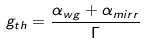<formula> <loc_0><loc_0><loc_500><loc_500>g _ { t h } = \frac { \alpha _ { w g } + \alpha _ { m i r r } } { \Gamma }</formula> 